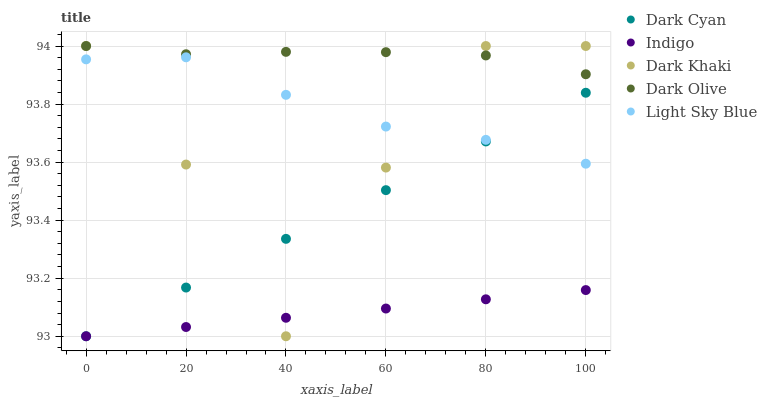Does Indigo have the minimum area under the curve?
Answer yes or no. Yes. Does Dark Olive have the maximum area under the curve?
Answer yes or no. Yes. Does Dark Khaki have the minimum area under the curve?
Answer yes or no. No. Does Dark Khaki have the maximum area under the curve?
Answer yes or no. No. Is Indigo the smoothest?
Answer yes or no. Yes. Is Dark Khaki the roughest?
Answer yes or no. Yes. Is Dark Olive the smoothest?
Answer yes or no. No. Is Dark Olive the roughest?
Answer yes or no. No. Does Dark Cyan have the lowest value?
Answer yes or no. Yes. Does Dark Khaki have the lowest value?
Answer yes or no. No. Does Dark Olive have the highest value?
Answer yes or no. Yes. Does Indigo have the highest value?
Answer yes or no. No. Is Dark Cyan less than Dark Olive?
Answer yes or no. Yes. Is Dark Olive greater than Light Sky Blue?
Answer yes or no. Yes. Does Dark Khaki intersect Dark Cyan?
Answer yes or no. Yes. Is Dark Khaki less than Dark Cyan?
Answer yes or no. No. Is Dark Khaki greater than Dark Cyan?
Answer yes or no. No. Does Dark Cyan intersect Dark Olive?
Answer yes or no. No. 